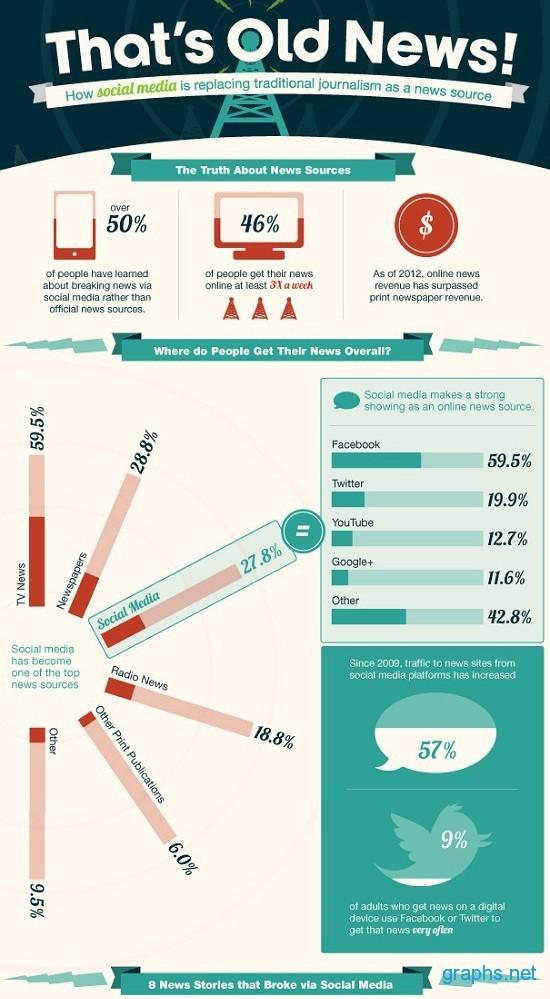Mention a couple of crucial points in this snapshot. YouTube is the fourth-most commonly used social media platform for reading news, according to a recent survey. Twitter is the third-most commonly used social media platform for reading news. The increase in the percentage of online news reading through social media has reached 57%. There were 8 instances of breaking news that were reported on social media. According to a recent survey, 46% of people read daily information online. 